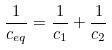<formula> <loc_0><loc_0><loc_500><loc_500>\frac { 1 } { c _ { e q } } = \frac { 1 } { c _ { 1 } } + \frac { 1 } { c _ { 2 } }</formula> 